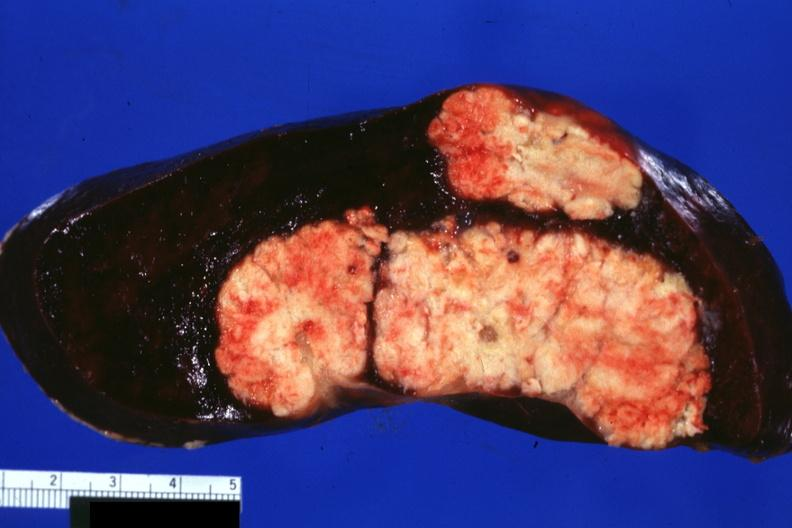where is this part in?
Answer the question using a single word or phrase. Spleen 